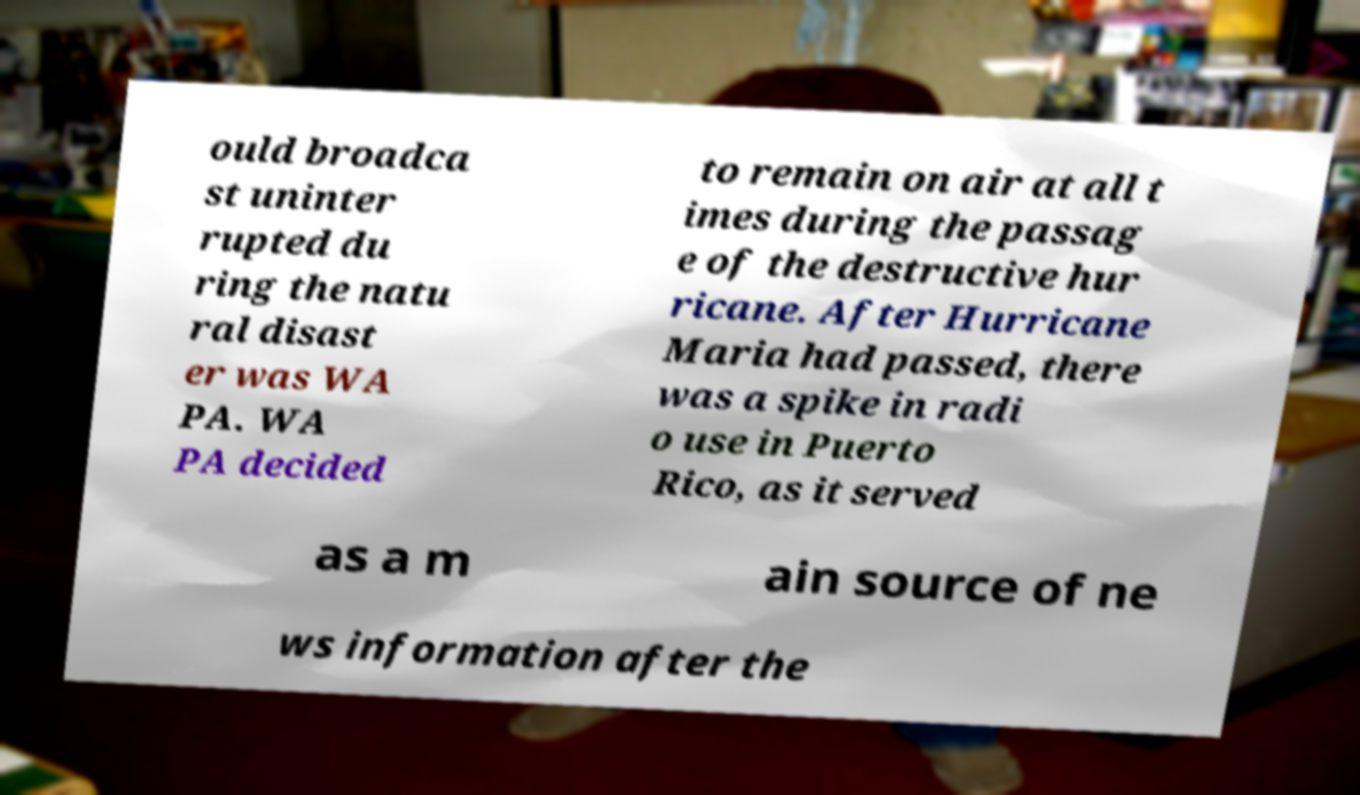Could you assist in decoding the text presented in this image and type it out clearly? ould broadca st uninter rupted du ring the natu ral disast er was WA PA. WA PA decided to remain on air at all t imes during the passag e of the destructive hur ricane. After Hurricane Maria had passed, there was a spike in radi o use in Puerto Rico, as it served as a m ain source of ne ws information after the 